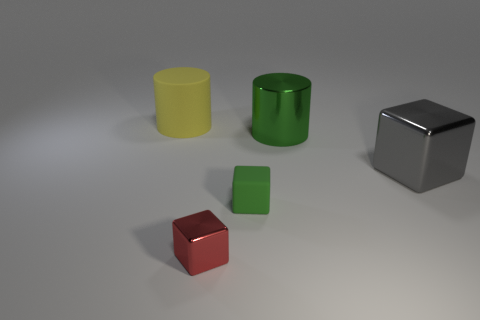Add 2 small green objects. How many objects exist? 7 Subtract all blocks. How many objects are left? 2 Subtract 0 cyan balls. How many objects are left? 5 Subtract all tiny gray rubber cubes. Subtract all big gray metallic cubes. How many objects are left? 4 Add 4 red metal blocks. How many red metal blocks are left? 5 Add 1 big red matte objects. How many big red matte objects exist? 1 